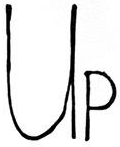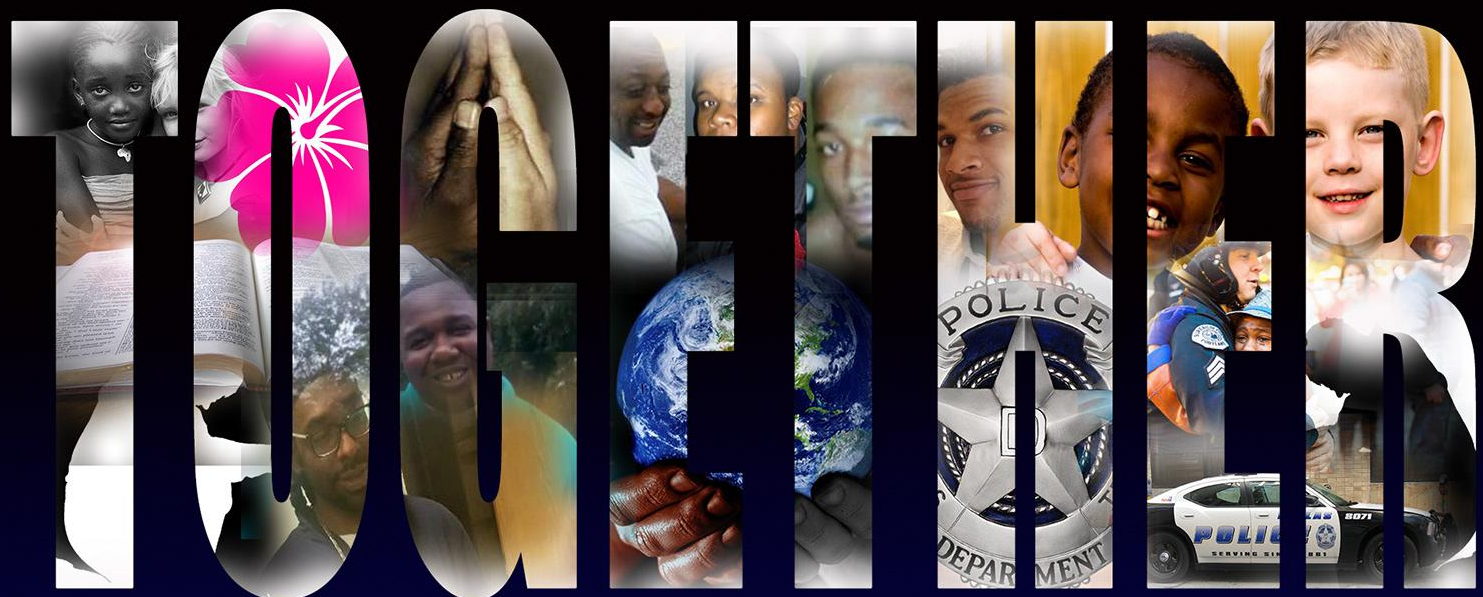Read the text from these images in sequence, separated by a semicolon. UP; TOGETHER 